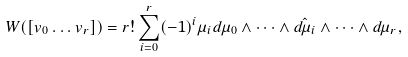<formula> <loc_0><loc_0><loc_500><loc_500>W ( [ v _ { 0 } \dots v _ { r } ] ) = r ! \sum _ { i = 0 } ^ { r } ( - 1 ) ^ { i } \mu _ { i } d \mu _ { 0 } \wedge \dots \wedge \hat { d \mu _ { i } } \wedge \dots \wedge d \mu _ { r } ,</formula> 